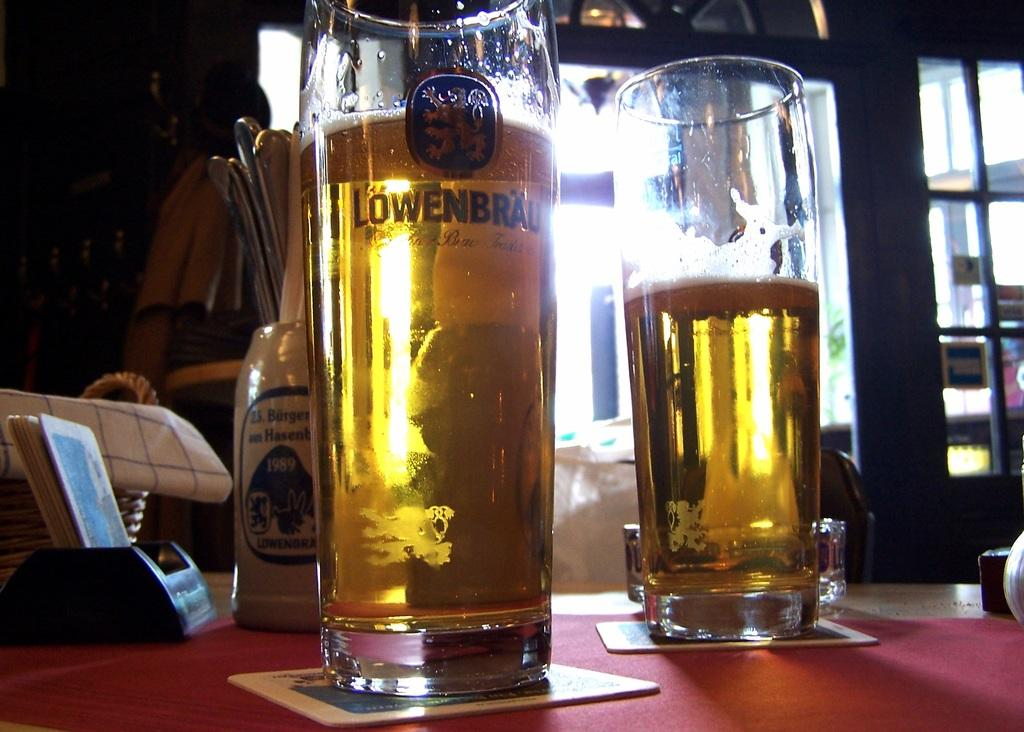Provide a one-sentence caption for the provided image. Two Lowenbrau glasses filled with beer sitting on a table. 